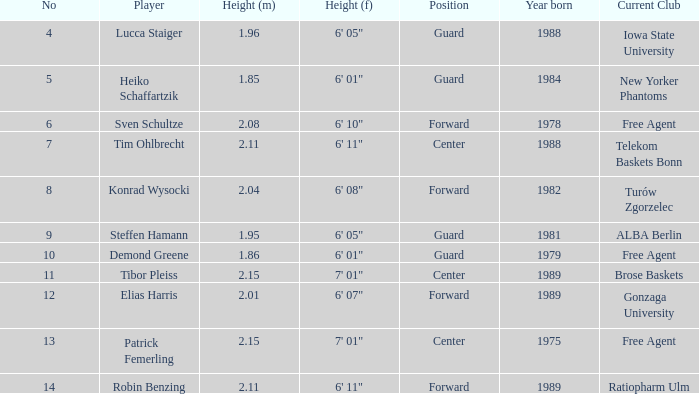Name the height for the player born in 1981 1.95. 